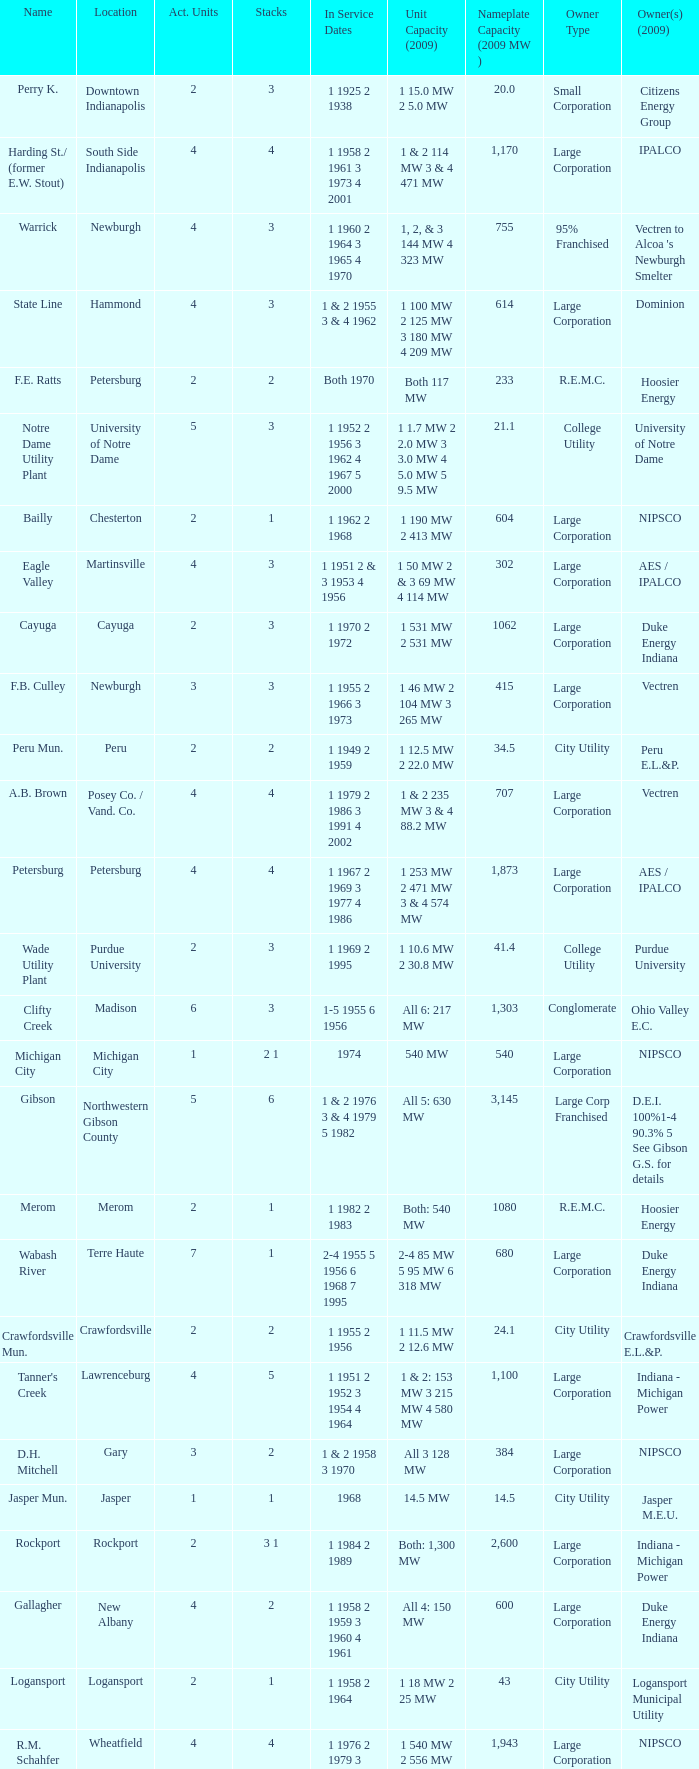Name the number of stacks for 1 & 2 235 mw 3 & 4 88.2 mw 1.0. 